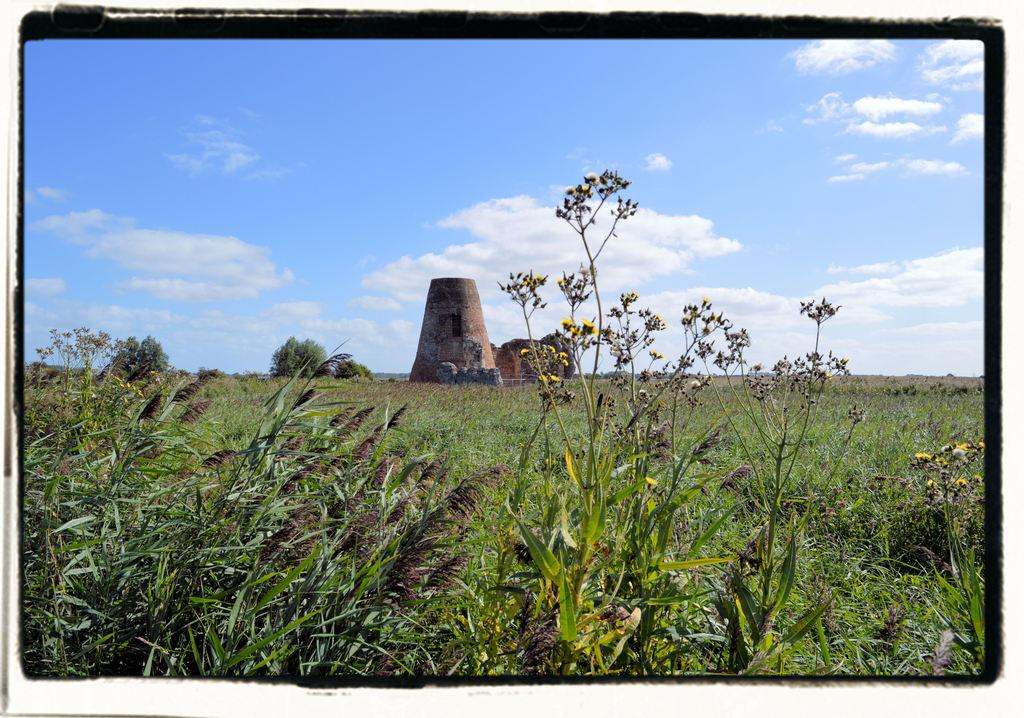What is the main structure in the center of the image? There is a tower in the center of the image. What type of terrain is visible at the bottom of the image? There is grass at the bottom of the image. What can be seen in the background of the image? The sky is visible in the background of the image. What type of boot is visible in the image? There is no boot present in the image. Is the grass covered in snow in the image? No, the grass is not covered in snow in the image; it is visible and green. 